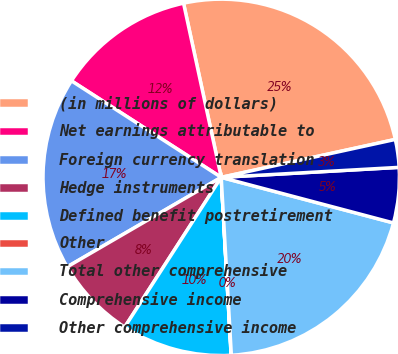Convert chart to OTSL. <chart><loc_0><loc_0><loc_500><loc_500><pie_chart><fcel>(in millions of dollars)<fcel>Net earnings attributable to<fcel>Foreign currency translation<fcel>Hedge instruments<fcel>Defined benefit postretirement<fcel>Other<fcel>Total other comprehensive<fcel>Comprehensive income<fcel>Other comprehensive income<nl><fcel>24.98%<fcel>12.5%<fcel>17.49%<fcel>7.51%<fcel>10.0%<fcel>0.02%<fcel>19.98%<fcel>5.01%<fcel>2.52%<nl></chart> 